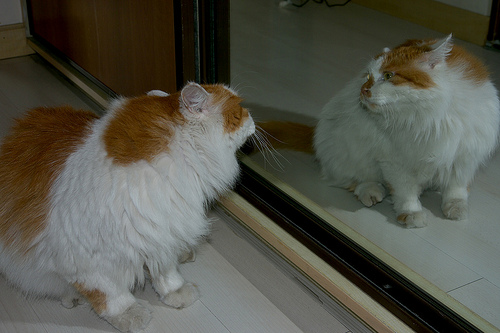<image>
Is the cat in front of the mirror? Yes. The cat is positioned in front of the mirror, appearing closer to the camera viewpoint. 